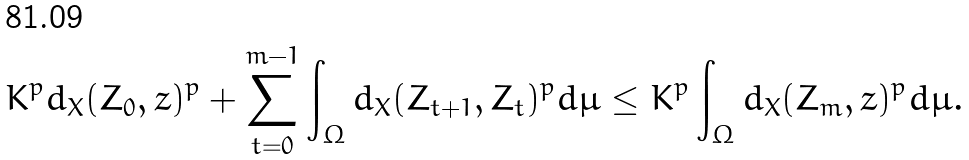Convert formula to latex. <formula><loc_0><loc_0><loc_500><loc_500>K ^ { p } d _ { X } ( Z _ { 0 } , z ) ^ { p } + \sum _ { t = 0 } ^ { m - 1 } \int _ { \Omega } d _ { X } ( Z _ { t + 1 } , Z _ { t } ) ^ { p } d \mu \leq K ^ { p } \int _ { \Omega } d _ { X } ( Z _ { m } , z ) ^ { p } d \mu .</formula> 